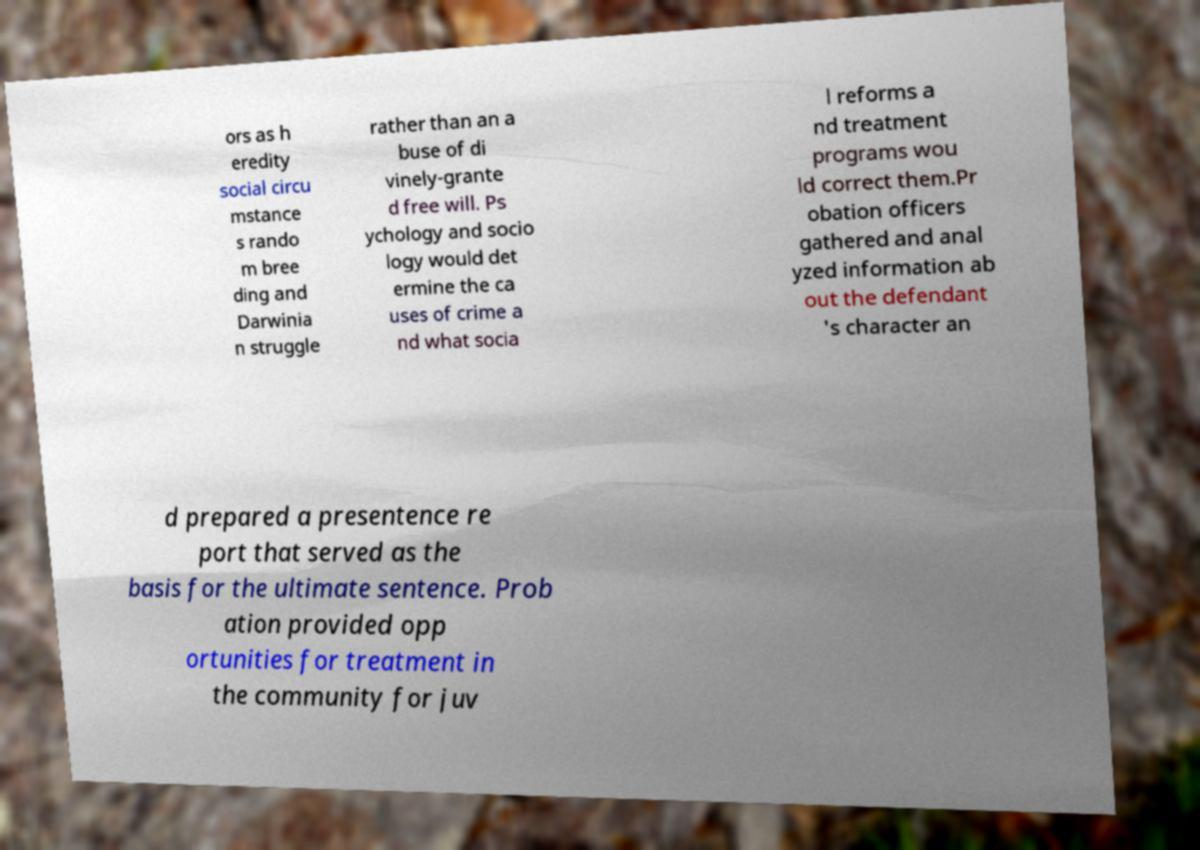Please read and relay the text visible in this image. What does it say? ors as h eredity social circu mstance s rando m bree ding and Darwinia n struggle rather than an a buse of di vinely-grante d free will. Ps ychology and socio logy would det ermine the ca uses of crime a nd what socia l reforms a nd treatment programs wou ld correct them.Pr obation officers gathered and anal yzed information ab out the defendant 's character an d prepared a presentence re port that served as the basis for the ultimate sentence. Prob ation provided opp ortunities for treatment in the community for juv 